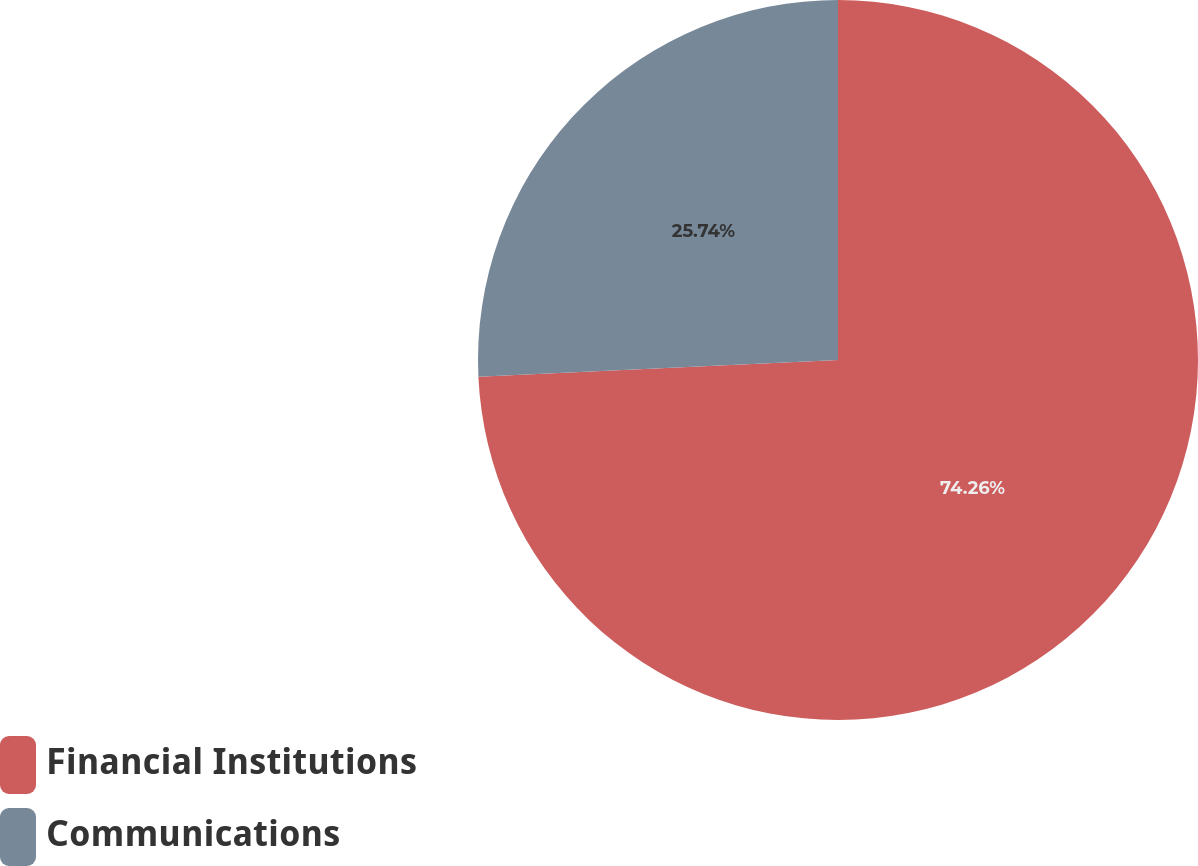Convert chart. <chart><loc_0><loc_0><loc_500><loc_500><pie_chart><fcel>Financial Institutions<fcel>Communications<nl><fcel>74.26%<fcel>25.74%<nl></chart> 